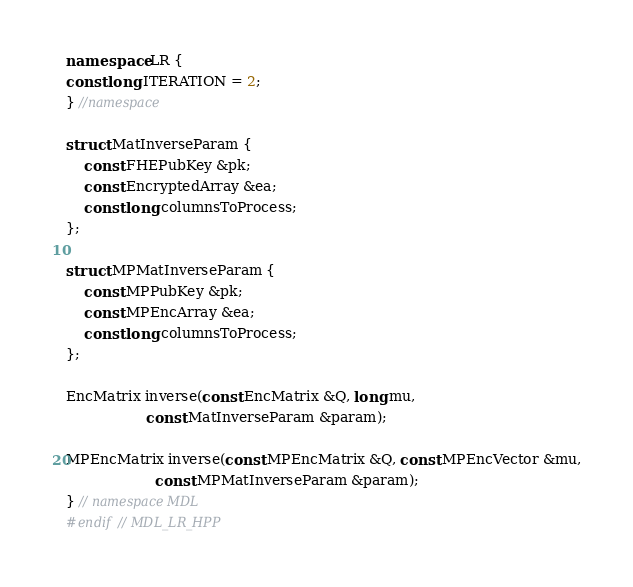Convert code to text. <code><loc_0><loc_0><loc_500><loc_500><_C++_>namespace LR {
const long ITERATION = 2;
} //namespace

struct MatInverseParam {
    const FHEPubKey &pk;
    const EncryptedArray &ea;
    const long columnsToProcess;
};

struct MPMatInverseParam {
    const MPPubKey &pk;
    const MPEncArray &ea;
    const long columnsToProcess;
};

EncMatrix inverse(const EncMatrix &Q, long mu,
                  const MatInverseParam &param);

MPEncMatrix inverse(const MPEncMatrix &Q, const MPEncVector &mu,
                    const MPMatInverseParam &param);
} // namespace MDL
#endif // MDL_LR_HPP
</code> 